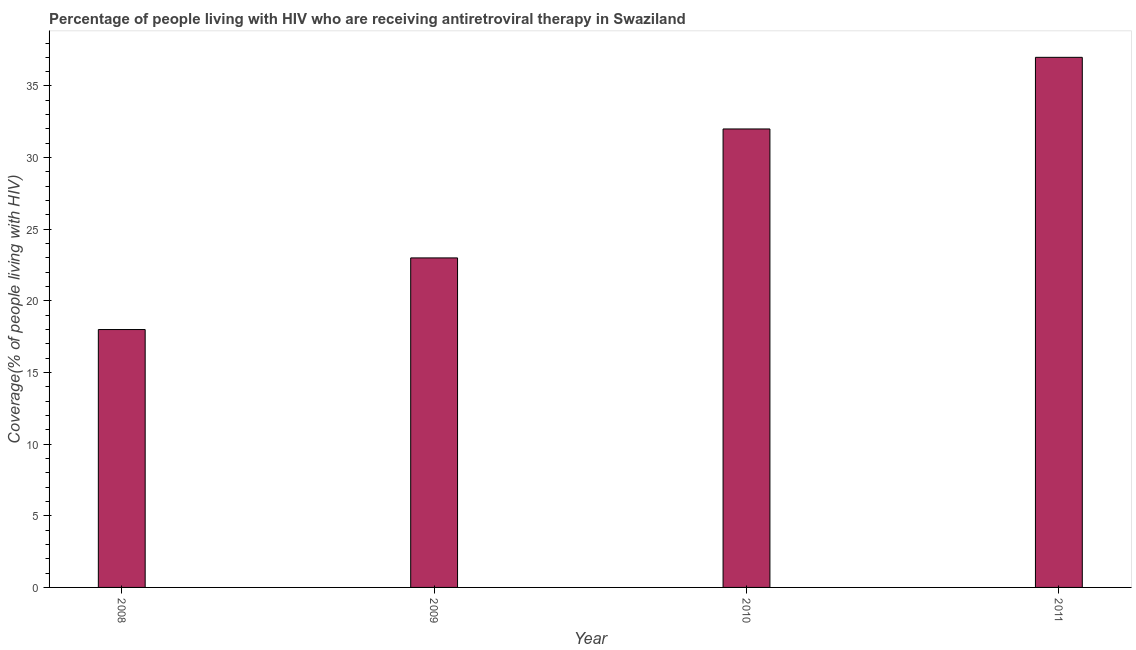Does the graph contain any zero values?
Your response must be concise. No. Does the graph contain grids?
Your answer should be compact. No. What is the title of the graph?
Your answer should be compact. Percentage of people living with HIV who are receiving antiretroviral therapy in Swaziland. What is the label or title of the X-axis?
Provide a succinct answer. Year. What is the label or title of the Y-axis?
Provide a short and direct response. Coverage(% of people living with HIV). What is the antiretroviral therapy coverage in 2008?
Your answer should be compact. 18. Across all years, what is the maximum antiretroviral therapy coverage?
Provide a short and direct response. 37. In which year was the antiretroviral therapy coverage minimum?
Your response must be concise. 2008. What is the sum of the antiretroviral therapy coverage?
Your answer should be compact. 110. What is the difference between the antiretroviral therapy coverage in 2009 and 2011?
Your response must be concise. -14. What is the median antiretroviral therapy coverage?
Your answer should be very brief. 27.5. Do a majority of the years between 2009 and 2010 (inclusive) have antiretroviral therapy coverage greater than 29 %?
Your answer should be compact. No. What is the ratio of the antiretroviral therapy coverage in 2008 to that in 2009?
Your response must be concise. 0.78. Is the antiretroviral therapy coverage in 2009 less than that in 2011?
Provide a short and direct response. Yes. Is the difference between the antiretroviral therapy coverage in 2008 and 2009 greater than the difference between any two years?
Your answer should be very brief. No. What is the difference between the highest and the second highest antiretroviral therapy coverage?
Make the answer very short. 5. Is the sum of the antiretroviral therapy coverage in 2010 and 2011 greater than the maximum antiretroviral therapy coverage across all years?
Provide a short and direct response. Yes. In how many years, is the antiretroviral therapy coverage greater than the average antiretroviral therapy coverage taken over all years?
Provide a short and direct response. 2. What is the difference between two consecutive major ticks on the Y-axis?
Provide a succinct answer. 5. Are the values on the major ticks of Y-axis written in scientific E-notation?
Offer a very short reply. No. What is the Coverage(% of people living with HIV) in 2011?
Your response must be concise. 37. What is the difference between the Coverage(% of people living with HIV) in 2008 and 2010?
Offer a very short reply. -14. What is the difference between the Coverage(% of people living with HIV) in 2010 and 2011?
Provide a succinct answer. -5. What is the ratio of the Coverage(% of people living with HIV) in 2008 to that in 2009?
Make the answer very short. 0.78. What is the ratio of the Coverage(% of people living with HIV) in 2008 to that in 2010?
Your response must be concise. 0.56. What is the ratio of the Coverage(% of people living with HIV) in 2008 to that in 2011?
Provide a succinct answer. 0.49. What is the ratio of the Coverage(% of people living with HIV) in 2009 to that in 2010?
Offer a very short reply. 0.72. What is the ratio of the Coverage(% of people living with HIV) in 2009 to that in 2011?
Keep it short and to the point. 0.62. What is the ratio of the Coverage(% of people living with HIV) in 2010 to that in 2011?
Offer a terse response. 0.86. 